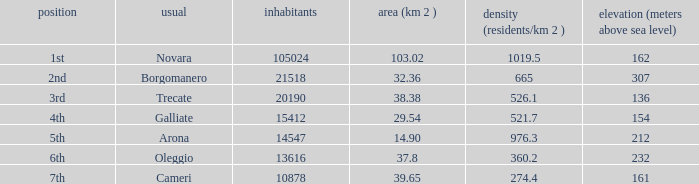Which common has an area (km2) of 103.02? Novara. 